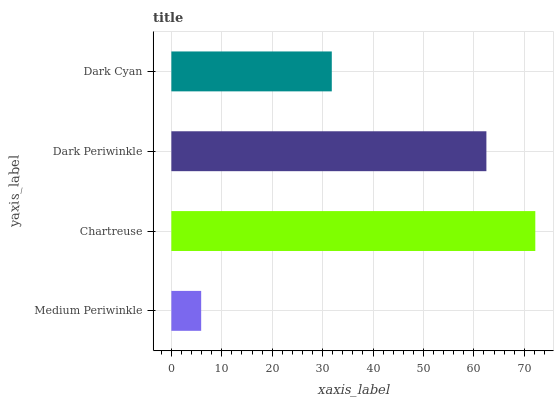Is Medium Periwinkle the minimum?
Answer yes or no. Yes. Is Chartreuse the maximum?
Answer yes or no. Yes. Is Dark Periwinkle the minimum?
Answer yes or no. No. Is Dark Periwinkle the maximum?
Answer yes or no. No. Is Chartreuse greater than Dark Periwinkle?
Answer yes or no. Yes. Is Dark Periwinkle less than Chartreuse?
Answer yes or no. Yes. Is Dark Periwinkle greater than Chartreuse?
Answer yes or no. No. Is Chartreuse less than Dark Periwinkle?
Answer yes or no. No. Is Dark Periwinkle the high median?
Answer yes or no. Yes. Is Dark Cyan the low median?
Answer yes or no. Yes. Is Chartreuse the high median?
Answer yes or no. No. Is Dark Periwinkle the low median?
Answer yes or no. No. 